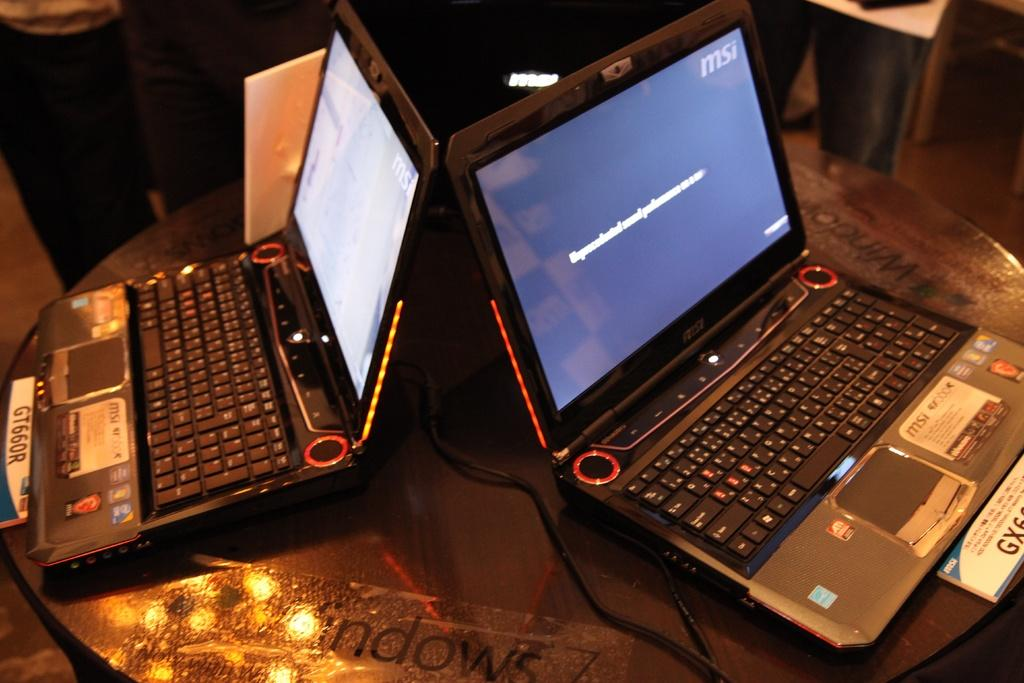What is located at the bottom of the image? There is a table at the bottom of the image. What objects are placed on the table? Laptops are placed on the table. Can you describe the people in the background of the image? There are people standing in the background of the image. What type of religion is being practiced by the people in the image? There is no indication of any religious practice in the image; it only shows a table with laptops and people standing in the background. 